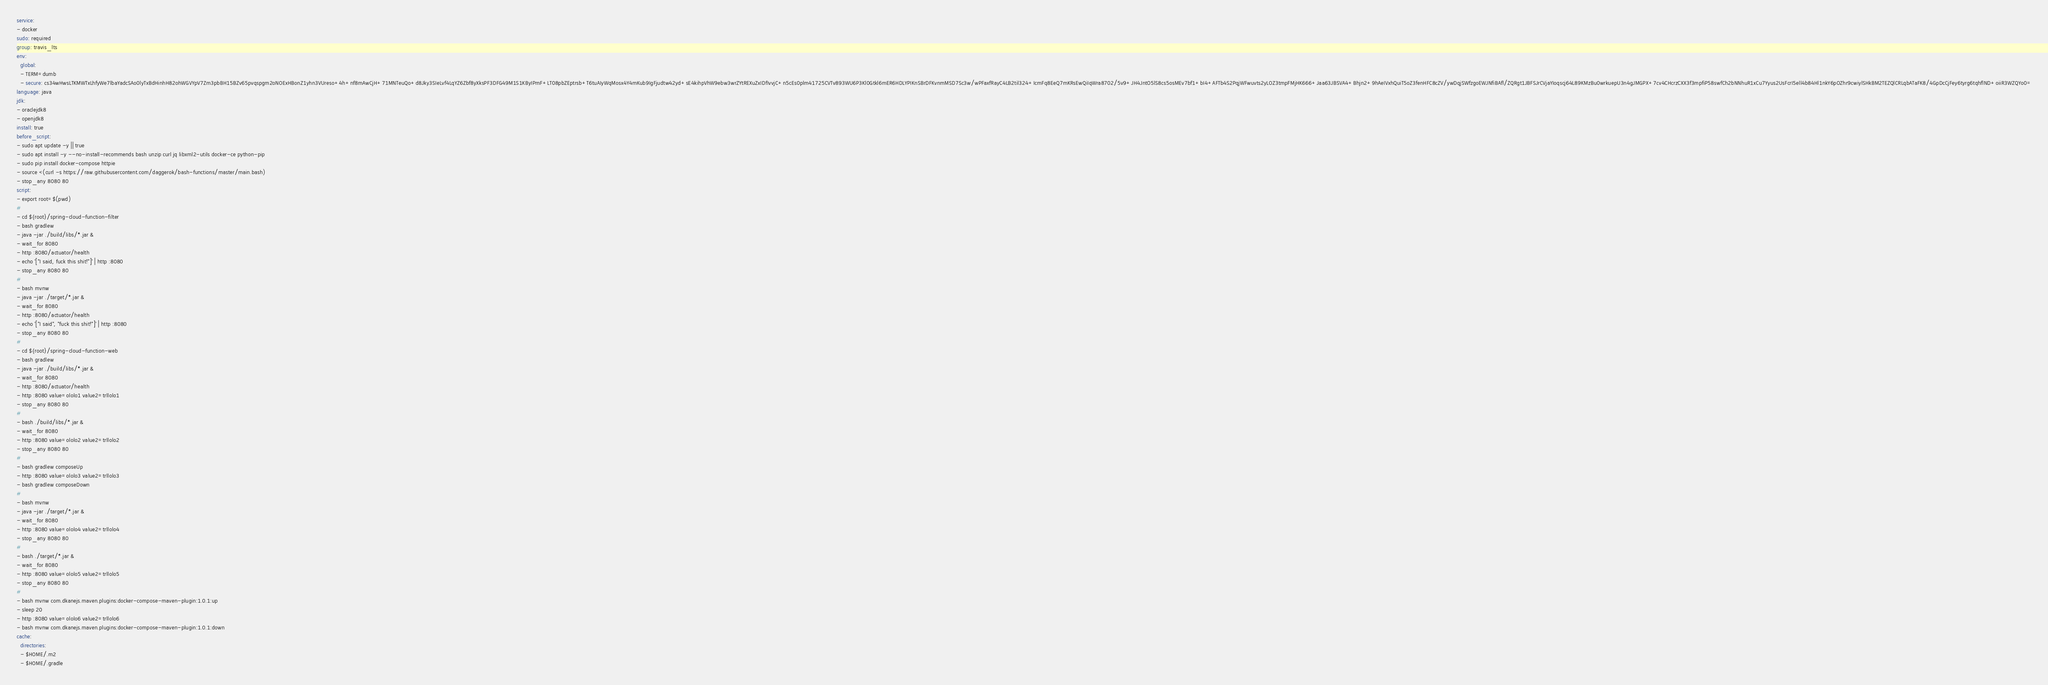Convert code to text. <code><loc_0><loc_0><loc_500><loc_500><_YAML_>service:
- docker
sudo: required
group: travis_lts
env:
  global:
  - TERM=dumb
  - secure: cs34wHwsLTKMWTxLhfyWe7lbaYadcSAo0lyTxBdHinhH82ohWGVYpV7Zm3pbBH15BZv65pvqspgm2oNOExHBonZ1yhn3VUreso+4h+nf8mAwCjH+71MNTeuQo+d8Jky3SIeLvf4LqYZ6Zbf8yXksPF3DFG49M1S1KByIPmF+LT08pbZEptrsb+T6tuAIyWqMosx4Y4mKub9IgFjudtw42yd+sE4kihpVhW9ebw3wrZYtREXuZxIDfIvvjC+n5cEs0plm41725CVTv893WU6P3Kl0Gtkl6mER6HDLYPIKnSBrDFKvnmMSD7Sc3w/wPFaxfRayC4LB2til324+IcmFq8EeQ7mKRsEwQiIqWra8702/5v9+JH4JntO5lS8cs5osMEv7bf1+bI4+AFTb4S2PqjWFwuvts2yLOZ3tmpFMjHK666+Jaa63JBSVA4+Bhjn2+9hAeIVxhQuiT5oZ3fenHFC8cZV/ywDqjSWfzgoEWJNfiBAfl/ZQRgt1JBFSJrCVjaYIoqscj64L89KMzBu0wrkuepU3n4gJMGPX+7cv4CHcrzCXX3f3mpfiP58swfCh2bNNhuR1xCu7Yyus2UsFcrI5ell4b84Hl1nkY6pOZhr9cwiylSHkBM2TEZQlCRLqbATaFK8/4GpDcCjFey6tyrg6tqhflND+oiiR3WZQYo0=
language: java
jdk:
- oraclejdk8
- openjdk8
install: true
before_script:
- sudo apt update -y || true
- sudo apt install -y --no-install-recommends bash unzip curl jq libxml2-utils docker-ce python-pip
- sudo pip install docker-compose httpie
- source <(curl -s https://raw.githubusercontent.com/daggerok/bash-functions/master/main.bash)
- stop_any 8080 80
script:
- export root=$(pwd)
#
- cd ${root}/spring-cloud-function-filter
- bash gradlew
- java -jar ./build/libs/*.jar &
- wait_for 8080
- http :8080/actuator/health
- echo '["I said, fuck this shit!"]' | http :8080
- stop_any 8080 80
#
- bash mvnw
- java -jar ./target/*.jar &
- wait_for 8080
- http :8080/actuator/health
- echo '["I said", "fuck this shit!"]' | http :8080
- stop_any 8080 80
#
- cd ${root}/spring-cloud-function-web
- bash gradlew
- java -jar ./build/libs/*.jar &
- wait_for 8080
- http :8080/actuator/health
- http :8080 value=ololo1 value2=trllolo1
- stop_any 8080 80
#
- bash ./build/libs/*.jar &
- wait_for 8080
- http :8080 value=ololo2 value2=trllolo2
- stop_any 8080 80
#
- bash gradlew composeUp
- http :8080 value=ololo3 value2=trllolo3
- bash gradlew composeDown
#
- bash mvnw
- java -jar ./target/*.jar &
- wait_for 8080
- http :8080 value=ololo4 value2=trllolo4
- stop_any 8080 80
#
- bash ./target/*.jar &
- wait_for 8080
- http :8080 value=ololo5 value2=trllolo5
- stop_any 8080 80
#
- bash mvnw com.dkanejs.maven.plugins:docker-compose-maven-plugin:1.0.1:up
- sleep 20
- http :8080 value=ololo6 value2=trllolo6
- bash mvnw com.dkanejs.maven.plugins:docker-compose-maven-plugin:1.0.1:down
cache:
  directories:
  - $HOME/.m2
  - $HOME/.gradle
</code> 